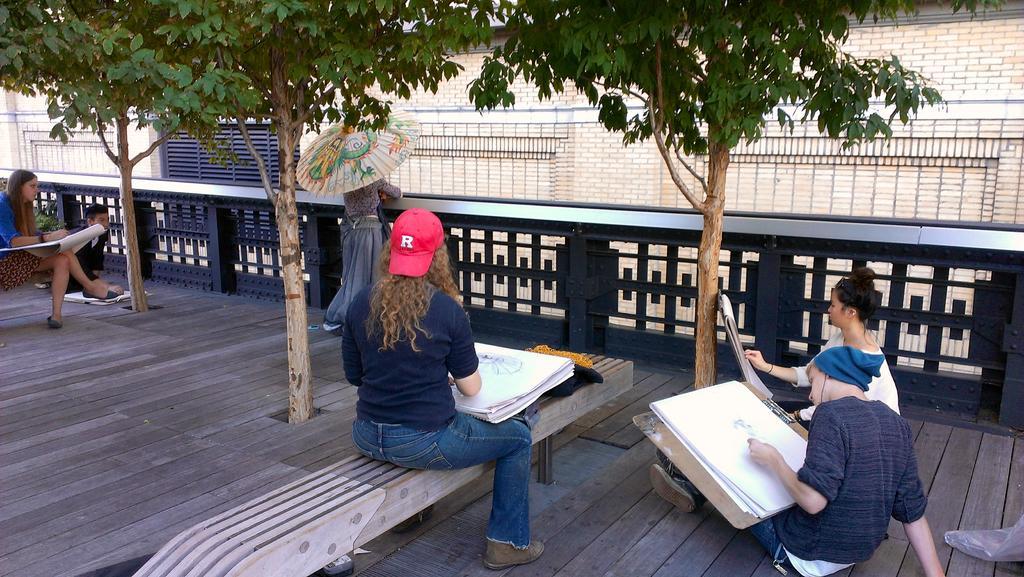Describe this image in one or two sentences. In this image I see few people who are on the path and most of them are holding papers in their hands and I see 3 trees and a fence. 